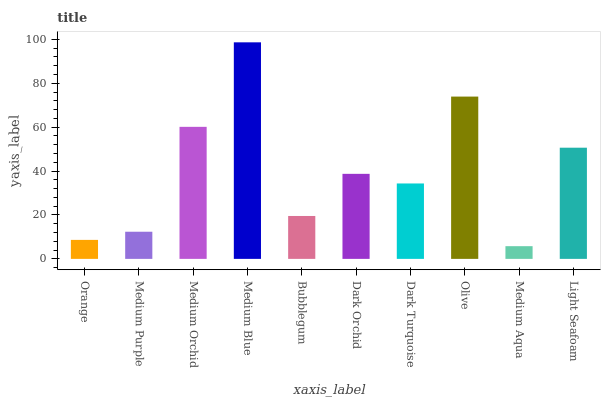Is Medium Purple the minimum?
Answer yes or no. No. Is Medium Purple the maximum?
Answer yes or no. No. Is Medium Purple greater than Orange?
Answer yes or no. Yes. Is Orange less than Medium Purple?
Answer yes or no. Yes. Is Orange greater than Medium Purple?
Answer yes or no. No. Is Medium Purple less than Orange?
Answer yes or no. No. Is Dark Orchid the high median?
Answer yes or no. Yes. Is Dark Turquoise the low median?
Answer yes or no. Yes. Is Bubblegum the high median?
Answer yes or no. No. Is Dark Orchid the low median?
Answer yes or no. No. 